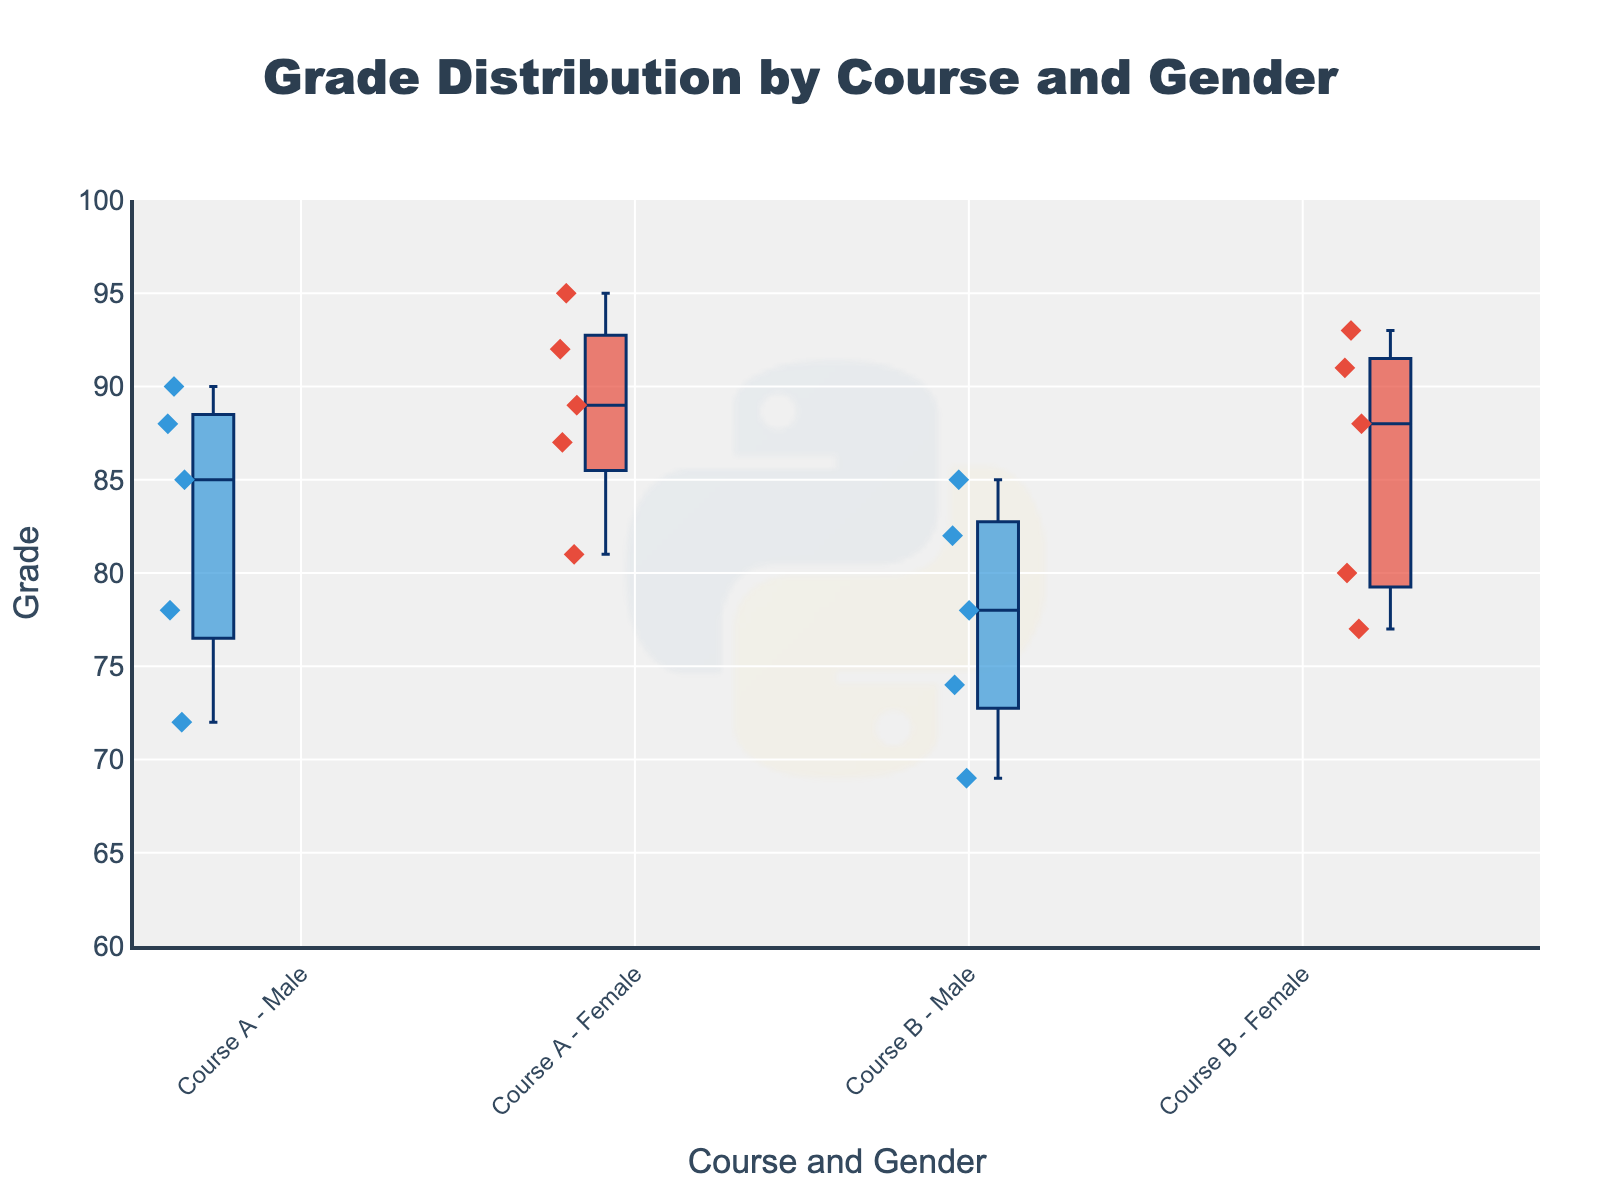What is the title of the plot? The title is displayed prominently at the top of the plot. It reads, "Grade Distribution by Course and Gender."
Answer: Grade Distribution by Course and Gender What does the y-axis represent? The y-axis label indicates that the y-axis represents the "Grade" values of the students.
Answer: Grade What are the colors used for male and female students? The boxplots are colored differently for males and females. Male students are represented using blue, while female students are represented using red.
Answer: Blue for male, red for female Which group has the highest median grade in Course A? To determine the highest median grade, we need to look at the central line inside each box plot for Course A. The Female group in Course A has the highest median grade, indicated by the line inside the box at a higher value compared to the Male group.
Answer: Female What is the range of grades for female students in Course B? To find the range, examine the minimum and maximum points (whiskers) of the box plot for female students in Course B. The lowest value is 77, and the highest value is 93. The range is calculated by subtracting the minimum from the maximum: 93 - 77 = 16.
Answer: 16 How many data points are there for male students in Course B? Each box plot uses small diamond markers to represent individual data points. Counting these markers for male students in Course B will give the total number of data points. There are 5 diamond markers for male students in Course B.
Answer: 5 Which course has the lower median grade for male students? Compare the central lines (medians) inside the male box plots for both courses. The median grade for males in Course B is lower than in Course A.
Answer: Course B What is the maximum grade recorded for male students in Course A? The upper whisker of the box plot for male students in Course A indicates the maximum recorded grade. The maximum grade recorded is 90.
Answer: 90 Compare the interquartile range (IQR) of grades between female students in both courses. The IQR is found between the bottom and top of the box. For female students, Course A has a narrower box compared to Course B, indicating a smaller IQR. Therefore, the IQR for female students in Course B is larger than in Course A.
Answer: Female students in Course B have a larger IQR Which group has the most consistent grades within each course? Consistency can be inferred from the extent of the boxplot’s whiskers and the box’s height. The male group in Course A has less variability (closer whiskers, smaller box height) compared to the other groups, indicating the most consistent grades.
Answer: Male group in Course A 